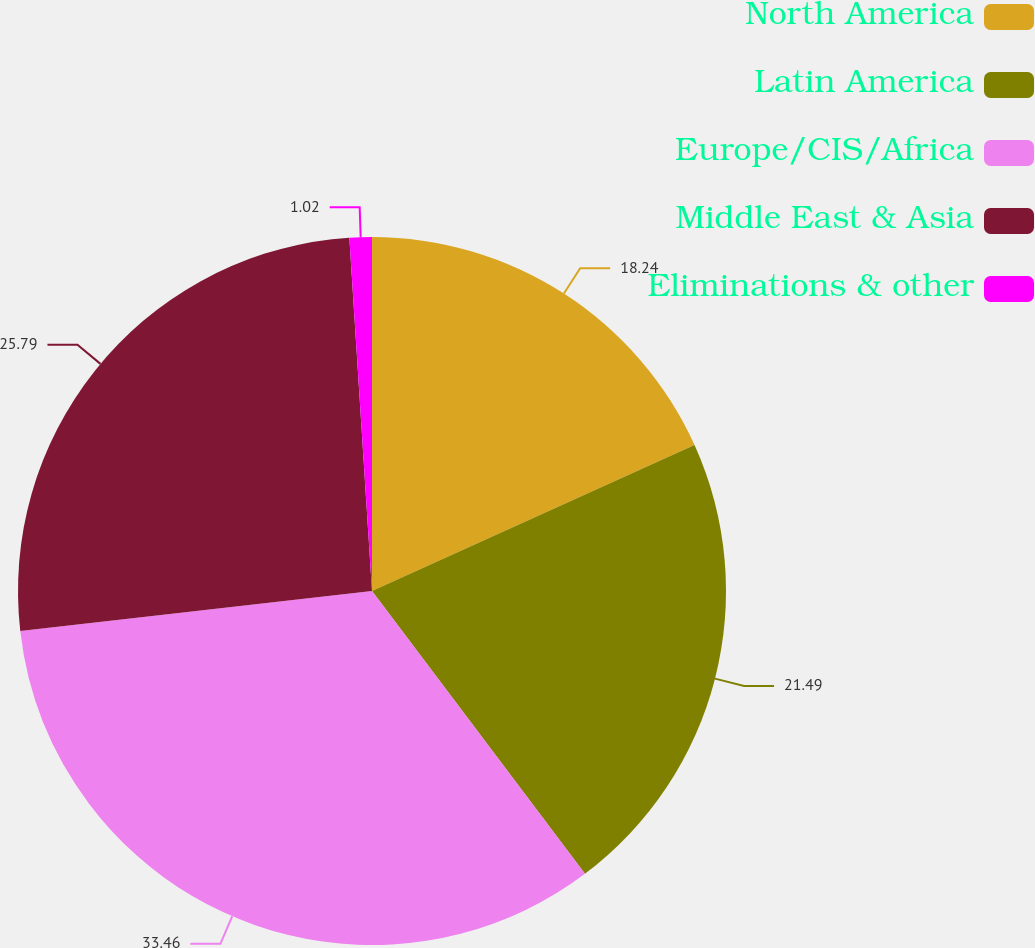Convert chart to OTSL. <chart><loc_0><loc_0><loc_500><loc_500><pie_chart><fcel>North America<fcel>Latin America<fcel>Europe/CIS/Africa<fcel>Middle East & Asia<fcel>Eliminations & other<nl><fcel>18.24%<fcel>21.49%<fcel>33.47%<fcel>25.79%<fcel>1.02%<nl></chart> 